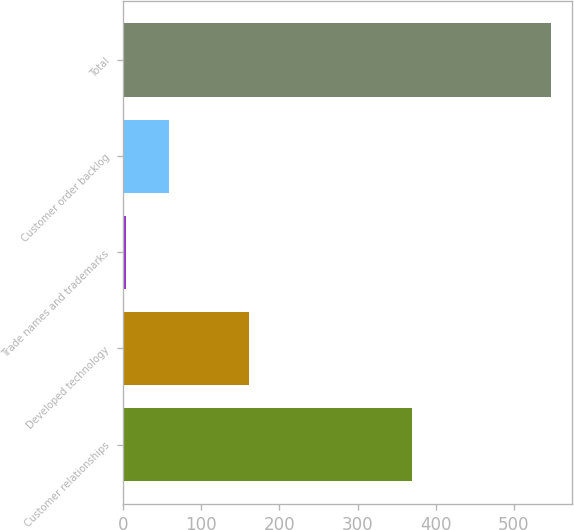Convert chart to OTSL. <chart><loc_0><loc_0><loc_500><loc_500><bar_chart><fcel>Customer relationships<fcel>Developed technology<fcel>Trade names and trademarks<fcel>Customer order backlog<fcel>Total<nl><fcel>370<fcel>161<fcel>4<fcel>58.3<fcel>547<nl></chart> 